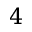Convert formula to latex. <formula><loc_0><loc_0><loc_500><loc_500>4</formula> 